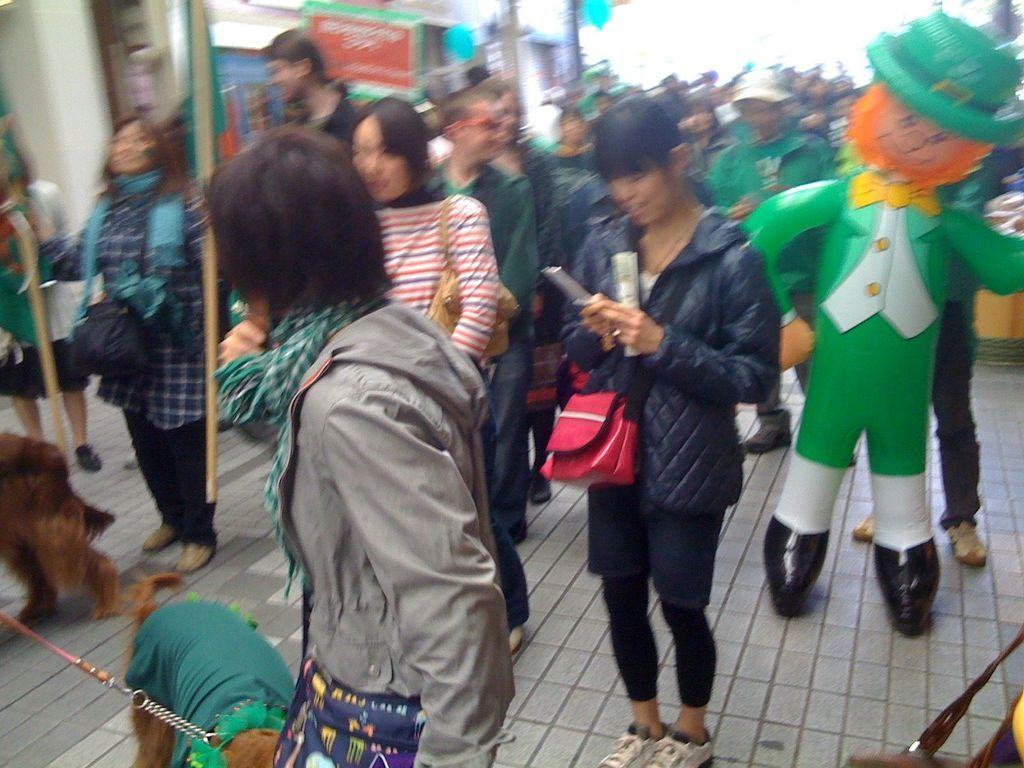What are the main subjects in the image? There are persons standing on the ground and dogs in the image. What else can be seen in the image besides the persons and dogs? There are toys and a board in the image. Is there any structure visible in the background? Yes, there is a building in the image. How would you describe the background of the image? The background of the image appears blurry. What type of jar is being used to play with the potato in the image? There is no jar or potato present in the image. How many bikes are visible in the image? There are no bikes visible in the image. 